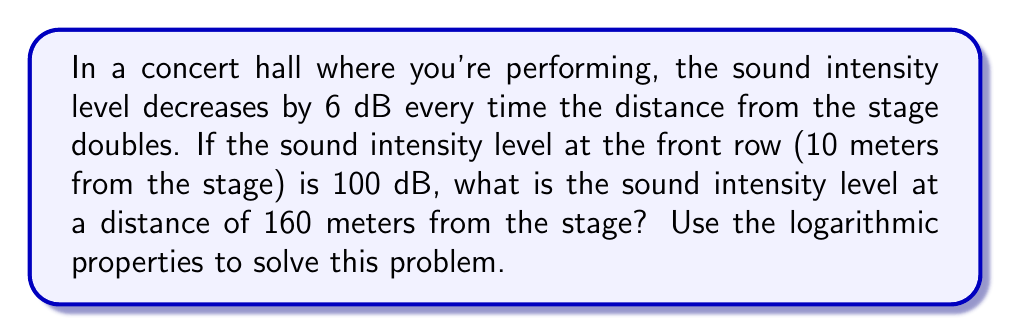Give your solution to this math problem. Let's approach this step-by-step:

1) First, we need to determine how many times the distance has doubled from 10 meters to 160 meters.
   
   $10 \cdot 2^n = 160$
   $2^n = 16$
   $n = \log_2 16 = 4$

   So the distance has doubled 4 times.

2) We're told that the sound intensity level decreases by 6 dB each time the distance doubles. So the total decrease will be:
   
   $6 \cdot 4 = 24$ dB

3) The initial sound intensity level is 100 dB, so the final level will be:
   
   $100 - 24 = 76$ dB

4) We can verify this using the logarithmic formula for sound intensity level:

   $L = L_0 - 10 \log_{10}\left(\frac{r^2}{r_0^2}\right)$

   Where $L$ is the final sound level, $L_0$ is the initial sound level, $r$ is the final distance, and $r_0$ is the initial distance.

5) Plugging in our values:

   $L = 100 - 10 \log_{10}\left(\frac{160^2}{10^2}\right)$
   
   $= 100 - 10 \log_{10}(256)$
   
   $= 100 - 10 \cdot 2.4082$
   
   $= 100 - 24.082$
   
   $= 75.918$ dB

6) This confirms our earlier calculation (with a small difference due to rounding).
Answer: 76 dB 